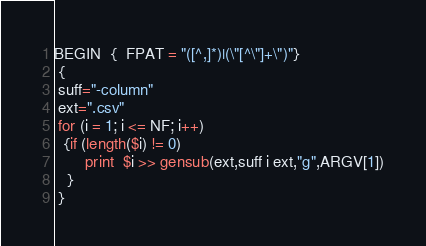Convert code to text. <code><loc_0><loc_0><loc_500><loc_500><_Awk_>BEGIN  {  FPAT = "([^,]*)|(\"[^\"]+\")"}
 {
 suff="-column"
 ext=".csv"
 for (i = 1; i <= NF; i++)
  {if (length($i) != 0)
       print  $i >> gensub(ext,suff i ext,"g",ARGV[1])
   }
 }</code> 